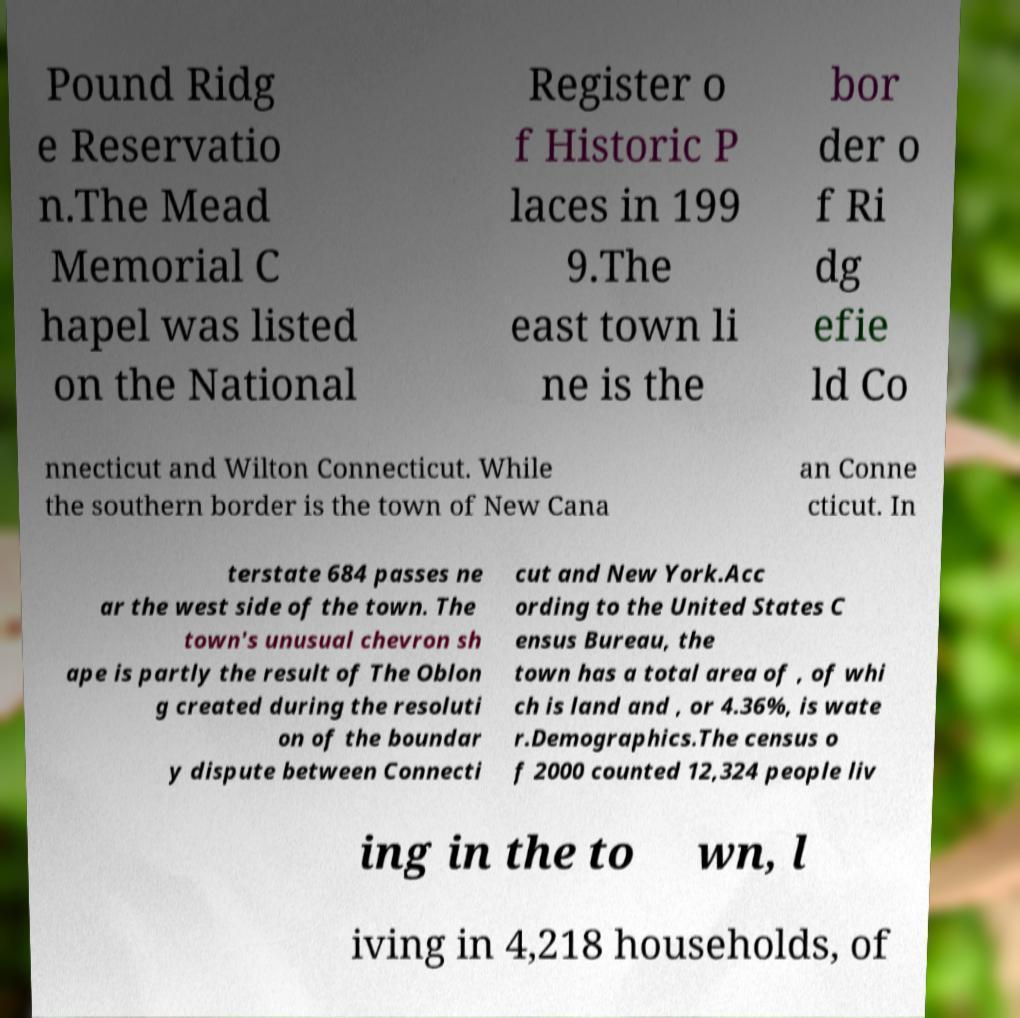Could you extract and type out the text from this image? Pound Ridg e Reservatio n.The Mead Memorial C hapel was listed on the National Register o f Historic P laces in 199 9.The east town li ne is the bor der o f Ri dg efie ld Co nnecticut and Wilton Connecticut. While the southern border is the town of New Cana an Conne cticut. In terstate 684 passes ne ar the west side of the town. The town's unusual chevron sh ape is partly the result of The Oblon g created during the resoluti on of the boundar y dispute between Connecti cut and New York.Acc ording to the United States C ensus Bureau, the town has a total area of , of whi ch is land and , or 4.36%, is wate r.Demographics.The census o f 2000 counted 12,324 people liv ing in the to wn, l iving in 4,218 households, of 